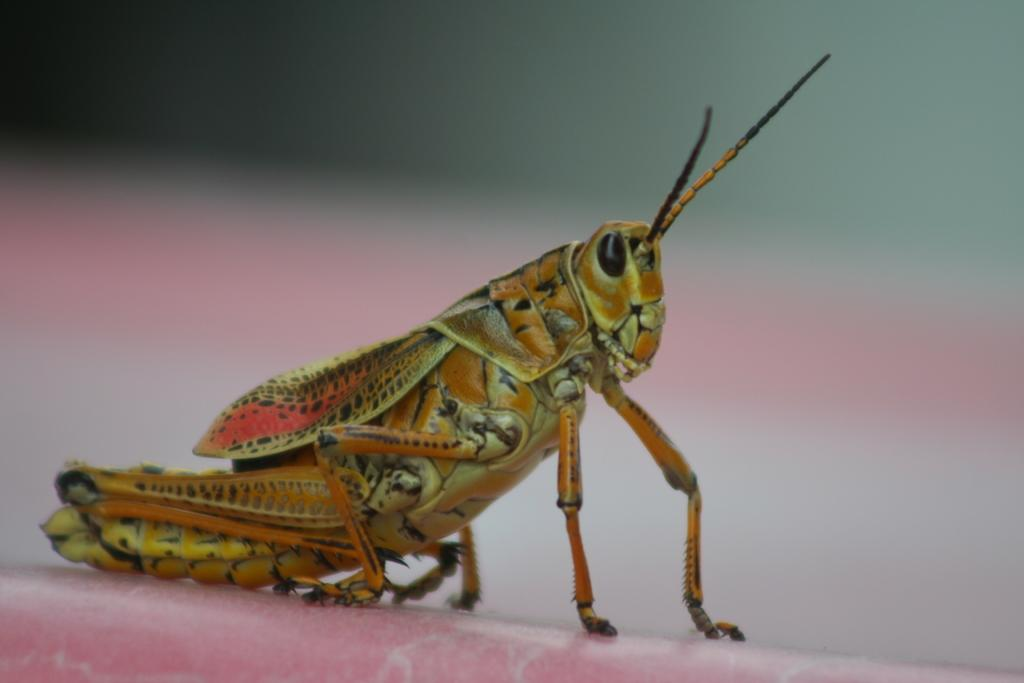What is the main subject of the image? There is a locust in the image. Can you describe the background of the image? The background of the image is blurred. What type of lawyer is depicted in the image? There is no lawyer present in the image; it features a locust. What color is the brick in the image? There is no brick present in the image. 